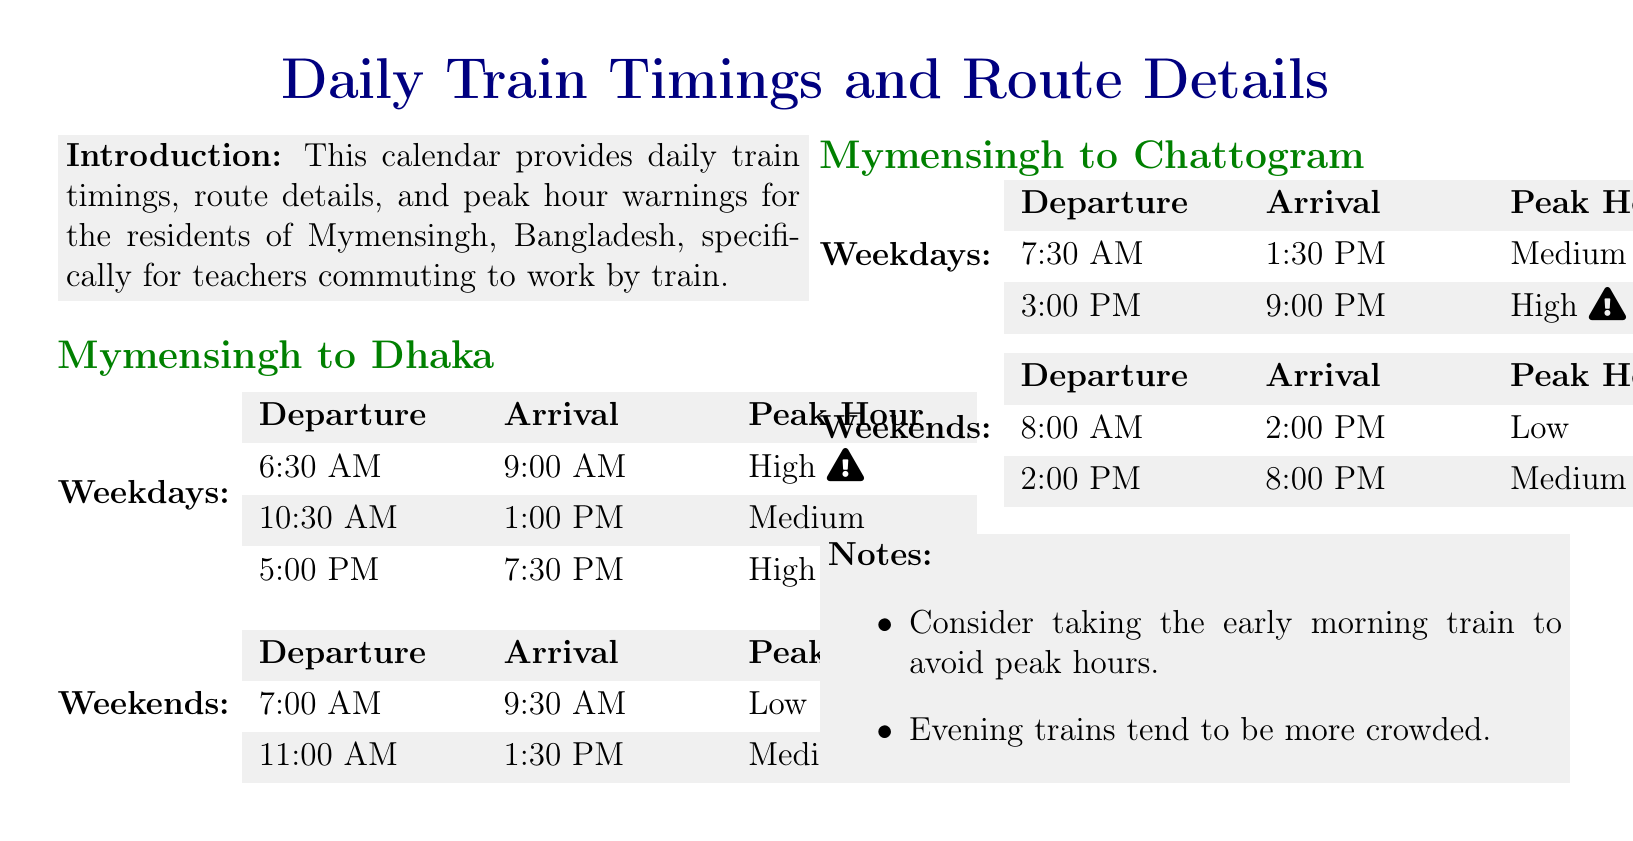What time does the train to Dhaka leave on weekdays? The document provides a specific time for departures on weekdays, which is 6:30 AM.
Answer: 6:30 AM What is the arrival time for the 10:30 AM train to Dhaka? The arrival time listed for the 10:30 AM departure to Dhaka is 1:00 PM.
Answer: 1:00 PM Is there a high peak hour warning for the evening train to Dhaka? The document indicates a high peak hour warning for the 5:00 PM train to Dhaka.
Answer: Yes What is the peak hour warning for the 7:00 AM train to Dhaka on weekends? The document states that the peak hour for the 7:00 AM train on weekends is low.
Answer: Low How many trains from Mymensingh to Chattogram have high peak hours on weekdays? The document specifies that there is one train from Mymensingh to Chattogram that has a high peak hour warning on weekdays, which is at 3:00 PM.
Answer: One What are the peak hours for the 8:00 AM train to Chattogram on weekends? The document indicates that the peak hour for the 8:00 AM train to Chattogram on weekends is low.
Answer: Low Which time slot should be avoided to mitigate crowding in the evening? The notes in the document suggest avoiding the evening train time slot from 5:00 PM to 7:30 PM to mitigate crowding.
Answer: 5:00 PM to 7:30 PM What is suggested for those who want to avoid peak hours? The notes recommend taking the early morning train to avoid peak hours.
Answer: Early morning train 